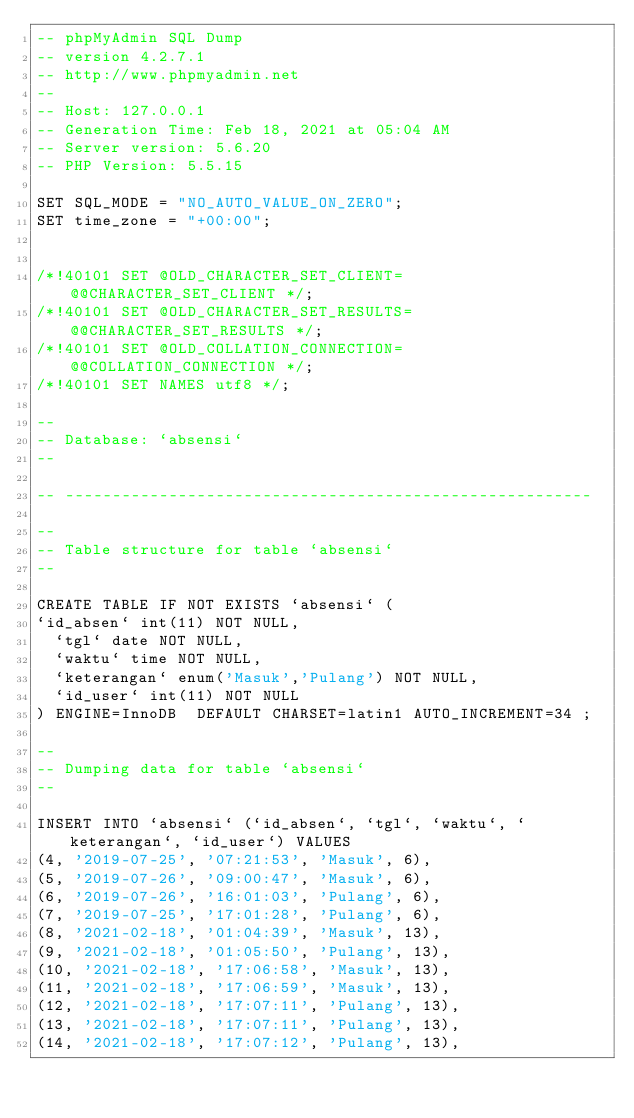<code> <loc_0><loc_0><loc_500><loc_500><_SQL_>-- phpMyAdmin SQL Dump
-- version 4.2.7.1
-- http://www.phpmyadmin.net
--
-- Host: 127.0.0.1
-- Generation Time: Feb 18, 2021 at 05:04 AM
-- Server version: 5.6.20
-- PHP Version: 5.5.15

SET SQL_MODE = "NO_AUTO_VALUE_ON_ZERO";
SET time_zone = "+00:00";


/*!40101 SET @OLD_CHARACTER_SET_CLIENT=@@CHARACTER_SET_CLIENT */;
/*!40101 SET @OLD_CHARACTER_SET_RESULTS=@@CHARACTER_SET_RESULTS */;
/*!40101 SET @OLD_COLLATION_CONNECTION=@@COLLATION_CONNECTION */;
/*!40101 SET NAMES utf8 */;

--
-- Database: `absensi`
--

-- --------------------------------------------------------

--
-- Table structure for table `absensi`
--

CREATE TABLE IF NOT EXISTS `absensi` (
`id_absen` int(11) NOT NULL,
  `tgl` date NOT NULL,
  `waktu` time NOT NULL,
  `keterangan` enum('Masuk','Pulang') NOT NULL,
  `id_user` int(11) NOT NULL
) ENGINE=InnoDB  DEFAULT CHARSET=latin1 AUTO_INCREMENT=34 ;

--
-- Dumping data for table `absensi`
--

INSERT INTO `absensi` (`id_absen`, `tgl`, `waktu`, `keterangan`, `id_user`) VALUES
(4, '2019-07-25', '07:21:53', 'Masuk', 6),
(5, '2019-07-26', '09:00:47', 'Masuk', 6),
(6, '2019-07-26', '16:01:03', 'Pulang', 6),
(7, '2019-07-25', '17:01:28', 'Pulang', 6),
(8, '2021-02-18', '01:04:39', 'Masuk', 13),
(9, '2021-02-18', '01:05:50', 'Pulang', 13),
(10, '2021-02-18', '17:06:58', 'Masuk', 13),
(11, '2021-02-18', '17:06:59', 'Masuk', 13),
(12, '2021-02-18', '17:07:11', 'Pulang', 13),
(13, '2021-02-18', '17:07:11', 'Pulang', 13),
(14, '2021-02-18', '17:07:12', 'Pulang', 13),</code> 